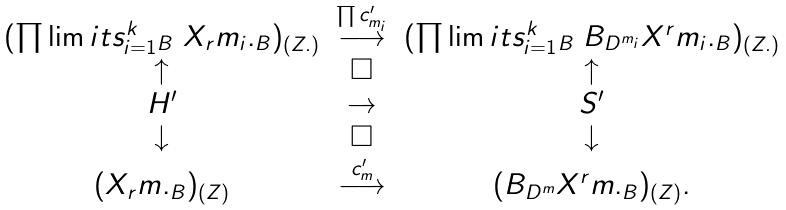<formula> <loc_0><loc_0><loc_500><loc_500>\begin{matrix} ( \prod \lim i t s _ { i = 1 } ^ { k } { _ { B } } \ X _ { r } m _ { i } . _ { B } ) _ { ( Z . ) } & \stackrel { \prod c ^ { \prime } _ { m _ { i } } } { \longrightarrow } & ( \prod \lim i t s _ { i = 1 } ^ { k } { _ { B } } \ B _ { D ^ { m _ { i } } } X ^ { r } m _ { i } . _ { B } ) _ { ( Z . ) } \\ \uparrow & \square & \uparrow \\ H ^ { \prime } & \to & S ^ { \prime } \\ \downarrow & \square & \downarrow \\ ( X _ { r } m . _ { B } ) _ { ( Z ) } & \stackrel { c ^ { \prime } _ { m } } { \longrightarrow } & ( B _ { D ^ { m } } X ^ { r } m . _ { B } ) _ { ( Z ) } . \end{matrix}</formula> 